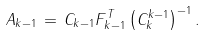Convert formula to latex. <formula><loc_0><loc_0><loc_500><loc_500>A _ { k - 1 } \, = \, C _ { k - 1 } F _ { k - 1 } ^ { T } \left ( C _ { k } ^ { k - 1 } \right ) ^ { - 1 } .</formula> 